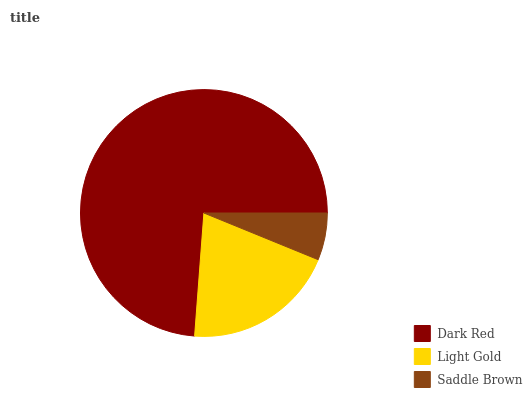Is Saddle Brown the minimum?
Answer yes or no. Yes. Is Dark Red the maximum?
Answer yes or no. Yes. Is Light Gold the minimum?
Answer yes or no. No. Is Light Gold the maximum?
Answer yes or no. No. Is Dark Red greater than Light Gold?
Answer yes or no. Yes. Is Light Gold less than Dark Red?
Answer yes or no. Yes. Is Light Gold greater than Dark Red?
Answer yes or no. No. Is Dark Red less than Light Gold?
Answer yes or no. No. Is Light Gold the high median?
Answer yes or no. Yes. Is Light Gold the low median?
Answer yes or no. Yes. Is Saddle Brown the high median?
Answer yes or no. No. Is Dark Red the low median?
Answer yes or no. No. 